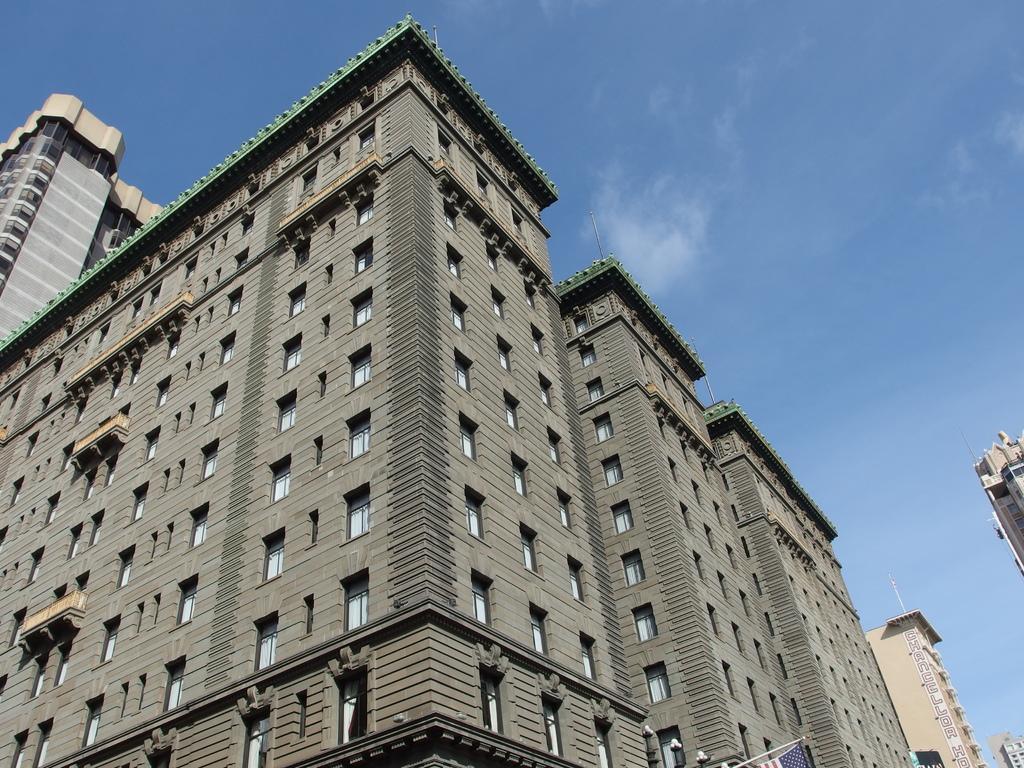How would you summarize this image in a sentence or two? Here we can see buildings. In the background there is sky. 